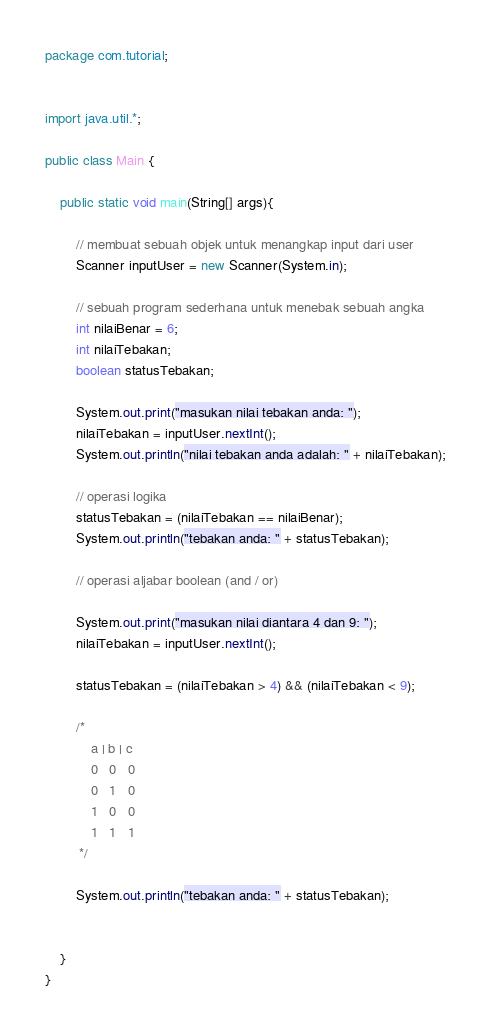Convert code to text. <code><loc_0><loc_0><loc_500><loc_500><_Java_>package com.tutorial;


import java.util.*;

public class Main {

    public static void main(String[] args){

        // membuat sebuah objek untuk menangkap input dari user
        Scanner inputUser = new Scanner(System.in);

        // sebuah program sederhana untuk menebak sebuah angka
        int nilaiBenar = 6;
        int nilaiTebakan;
        boolean statusTebakan;

        System.out.print("masukan nilai tebakan anda: ");
        nilaiTebakan = inputUser.nextInt();
        System.out.println("nilai tebakan anda adalah: " + nilaiTebakan);

        // operasi logika
        statusTebakan = (nilaiTebakan == nilaiBenar);
        System.out.println("tebakan anda: " + statusTebakan);

        // operasi aljabar boolean (and / or)

        System.out.print("masukan nilai diantara 4 dan 9: ");
        nilaiTebakan = inputUser.nextInt();

        statusTebakan = (nilaiTebakan > 4) && (nilaiTebakan < 9);

        /*
            a | b | c
            0   0   0
            0   1   0
            1   0   0
            1   1   1
         */

        System.out.println("tebakan anda: " + statusTebakan);


    }
}
</code> 